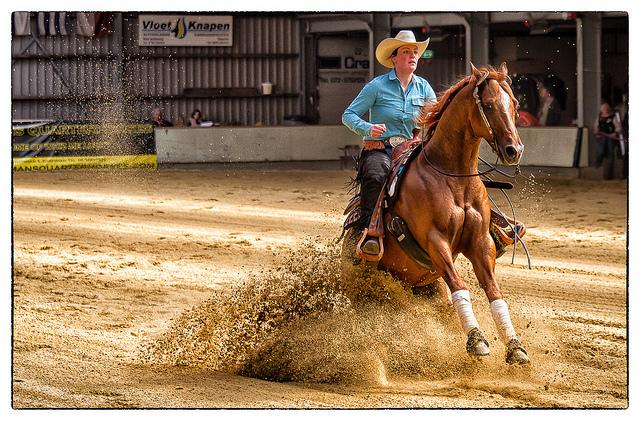Why is the horse on the the ground? Please explain your reasoning. fell. It looks like the horse lost traction by the dirt being kicked up and it falling makes the most sense. 